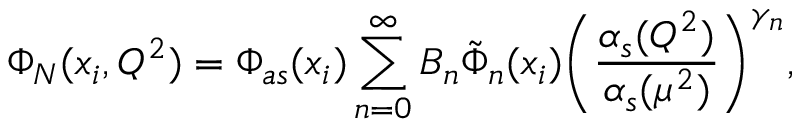Convert formula to latex. <formula><loc_0><loc_0><loc_500><loc_500>\Phi _ { N } ( x _ { i } , Q ^ { 2 } ) = \Phi _ { a s } ( x _ { i } ) \sum _ { n = 0 } ^ { \infty } B _ { n } \tilde { \Phi } _ { n } ( x _ { i } ) \left ( \frac { \alpha _ { s } ( Q ^ { 2 } ) } { \alpha _ { s } ( \mu ^ { 2 } ) } \right ) ^ { \gamma _ { n } } ,</formula> 